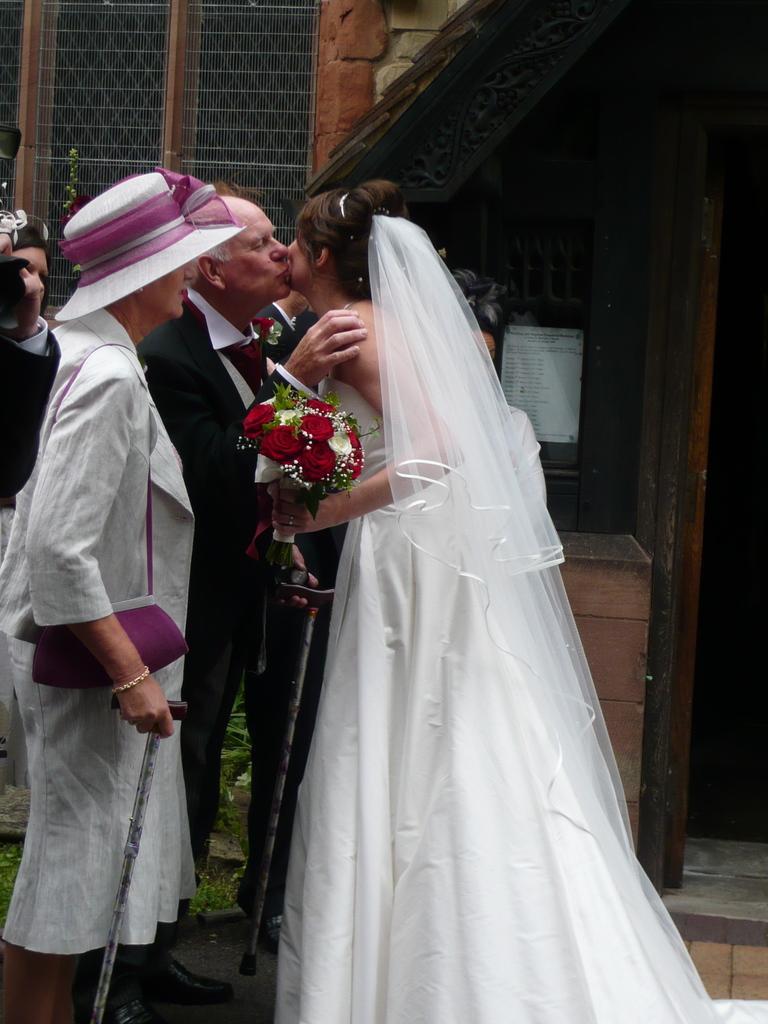Please provide a concise description of this image. In this picture I can see a man and a woman are kissing each other in the middle. This woman is also holding the flowers with her hand, on the left side I can see two persons. In the background there is a building. 